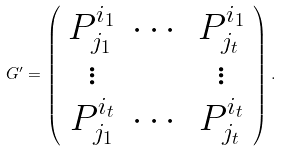Convert formula to latex. <formula><loc_0><loc_0><loc_500><loc_500>G ^ { \prime } = \left ( \begin{array} { c c c } P _ { j _ { 1 } } ^ { i _ { 1 } } & \cdots & P _ { j _ { t } } ^ { i _ { 1 } } \\ \vdots & & \vdots \\ P _ { j _ { 1 } } ^ { i _ { t } } & \cdots & P _ { j _ { t } } ^ { i _ { t } } \end{array} \right ) .</formula> 